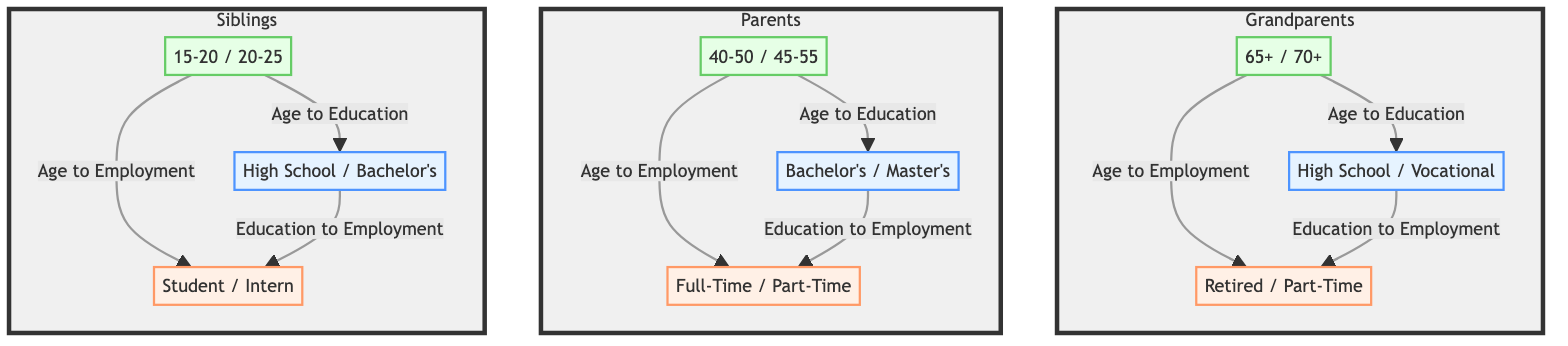What age group corresponds to the grandparents? The age group for the grandparents is indicated in the diagram as "65+ / 70+" which explicitly states the range for this family member category.
Answer: 65+ / 70+ What is the education level of the parents? The node representing the education level for parents clearly states "Bachelor's / Master's," directly providing the educational background for that age group.
Answer: Bachelor's / Master's How many employment types are represented for siblings? The diagram shows only one employment type for siblings, which is "Student / Intern," therefore there is only one type represented for this group.
Answer: 1 What is the relationship between grandparents' education and employment? The diagram indicates a flow from the "High School / Vocational" education level to the "Retired / Part-Time" employment for grandparents, showing a direct relationship between education level and employment type for that age group.
Answer: Education to Employment Which age group has the highest education level? By comparing the education levels in the diagram, "Bachelor's / Master's" for parents is higher than "High School / Bachelor's" for siblings and grandparents, making it clear that parents have the highest education level in this structure.
Answer: Parents What type of employment do parents have? The diagram lists employment types for parents as "Full-Time / Part-Time," providing specific information on the working status of this family member category.
Answer: Full-Time / Part-Time How does age influence employment type for grandparents? The flow from "65+ / 70+" age group to the "Retired / Part-Time" employment type indicates that as individuals reach this age group, they are likely to shift into retirement or part-time work.
Answer: Retired / Part-Time What connects the "Siblings" age group to their education level? The diagram shows a direct connection from the "15-20 / 20-25" age group to the education level "High School / Bachelor's," indicating that age directly influences the education level for siblings.
Answer: Age to Education 